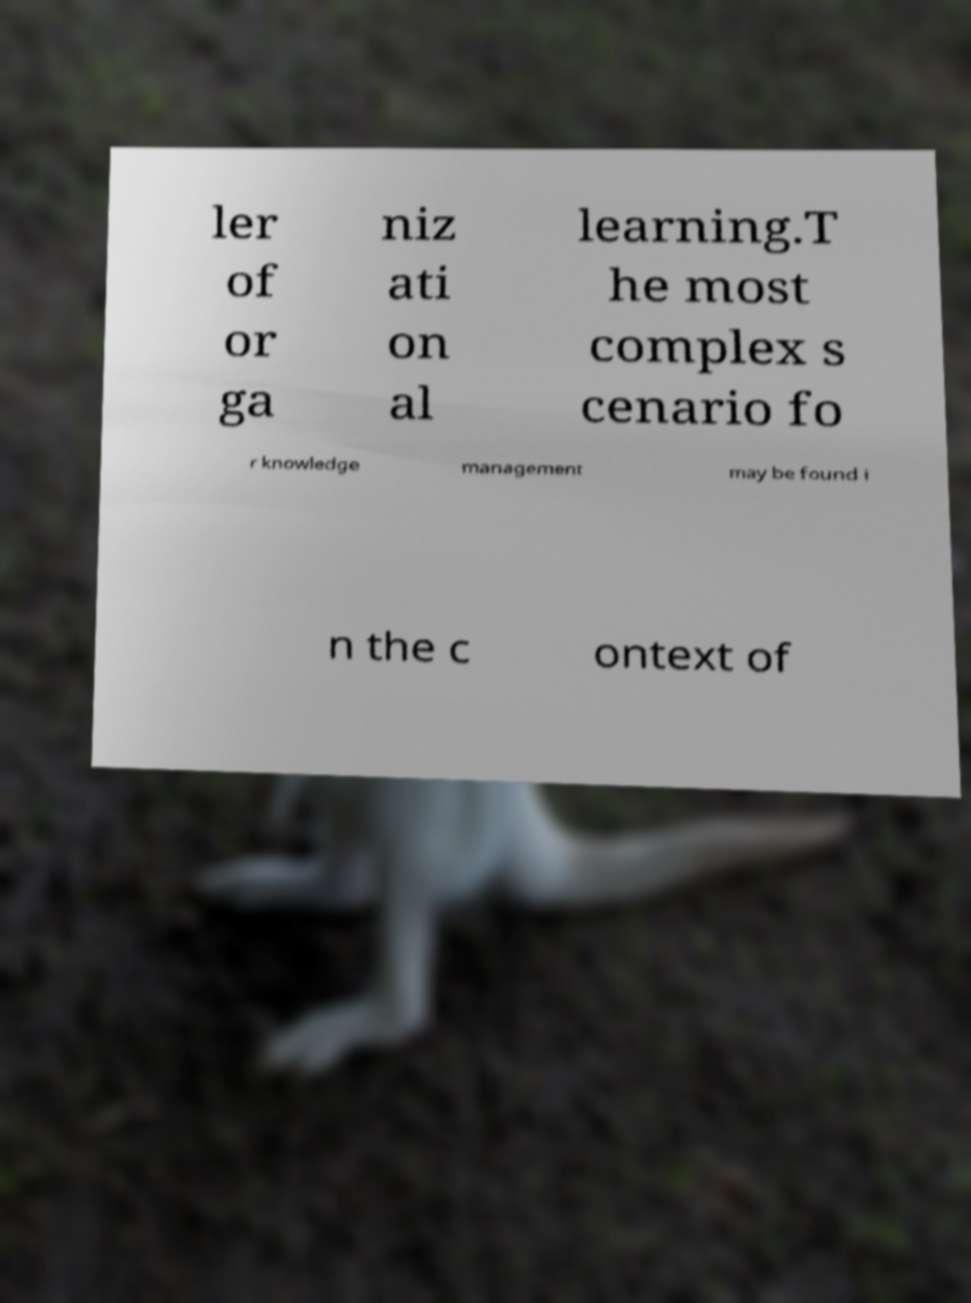There's text embedded in this image that I need extracted. Can you transcribe it verbatim? ler of or ga niz ati on al learning.T he most complex s cenario fo r knowledge management may be found i n the c ontext of 